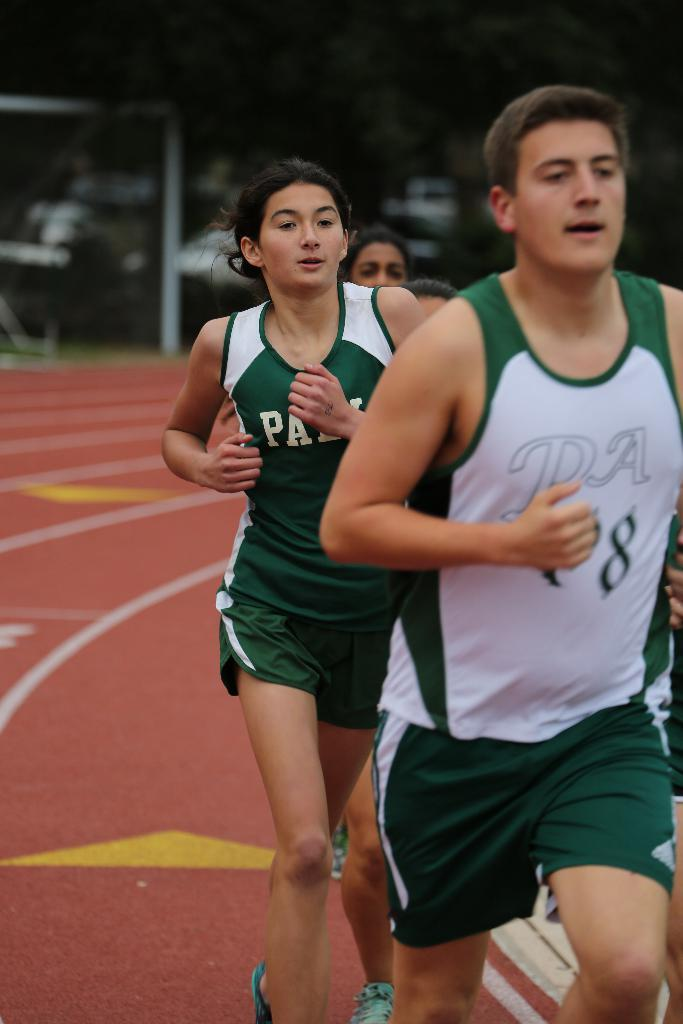<image>
Give a short and clear explanation of the subsequent image. A person wearing a white and green shirt that has the number 8 runs on a track with other people. 